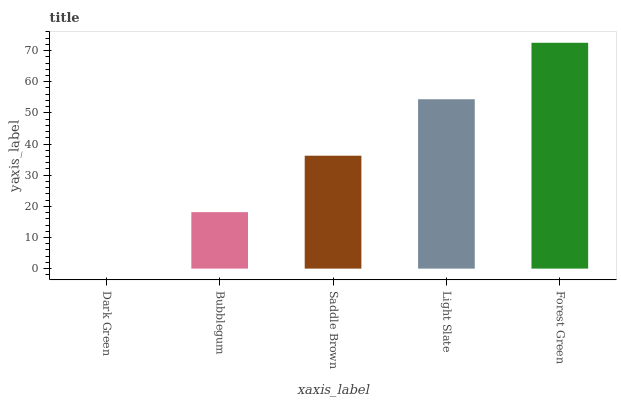Is Dark Green the minimum?
Answer yes or no. Yes. Is Forest Green the maximum?
Answer yes or no. Yes. Is Bubblegum the minimum?
Answer yes or no. No. Is Bubblegum the maximum?
Answer yes or no. No. Is Bubblegum greater than Dark Green?
Answer yes or no. Yes. Is Dark Green less than Bubblegum?
Answer yes or no. Yes. Is Dark Green greater than Bubblegum?
Answer yes or no. No. Is Bubblegum less than Dark Green?
Answer yes or no. No. Is Saddle Brown the high median?
Answer yes or no. Yes. Is Saddle Brown the low median?
Answer yes or no. Yes. Is Bubblegum the high median?
Answer yes or no. No. Is Forest Green the low median?
Answer yes or no. No. 